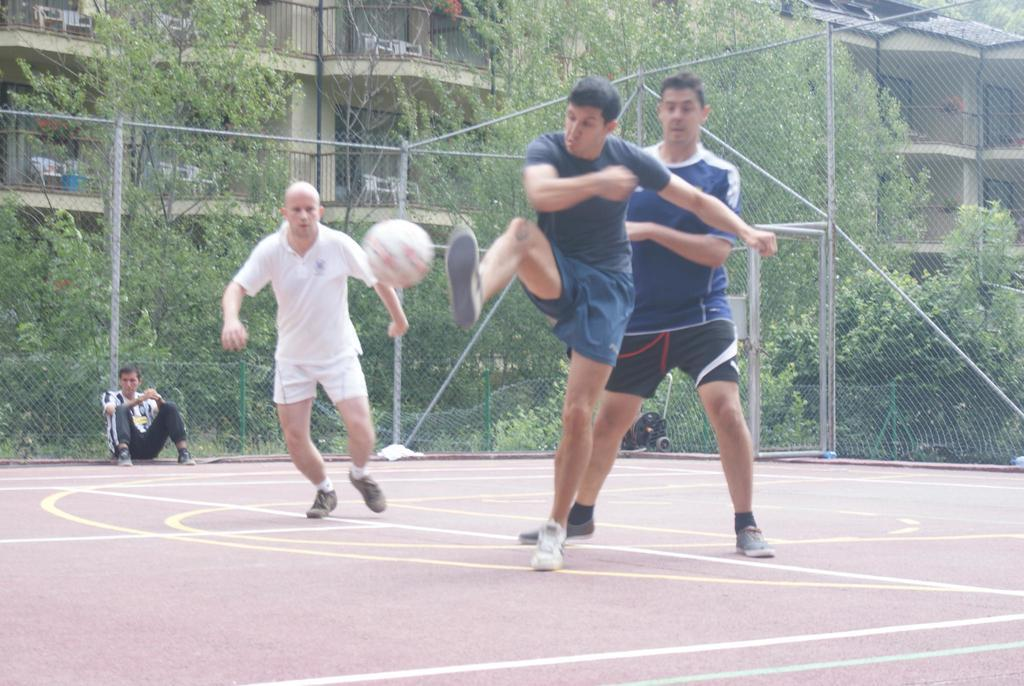Who or what can be seen in the image? There are people in the image. What object is present in the image that can be used for playing or sports? There is a ball in the image. What type of barrier can be seen in the image? There is a fence in the image. What type of natural elements are present in the image? There are trees in the image. What type of man-made structures can be seen in the image? There are buildings in the image. What type of waste can be seen in the image? There is no waste present in the image. What flavor of ice cream are the people eating in the image? There is no ice cream present in the image, so it is not possible to determine the flavor. 